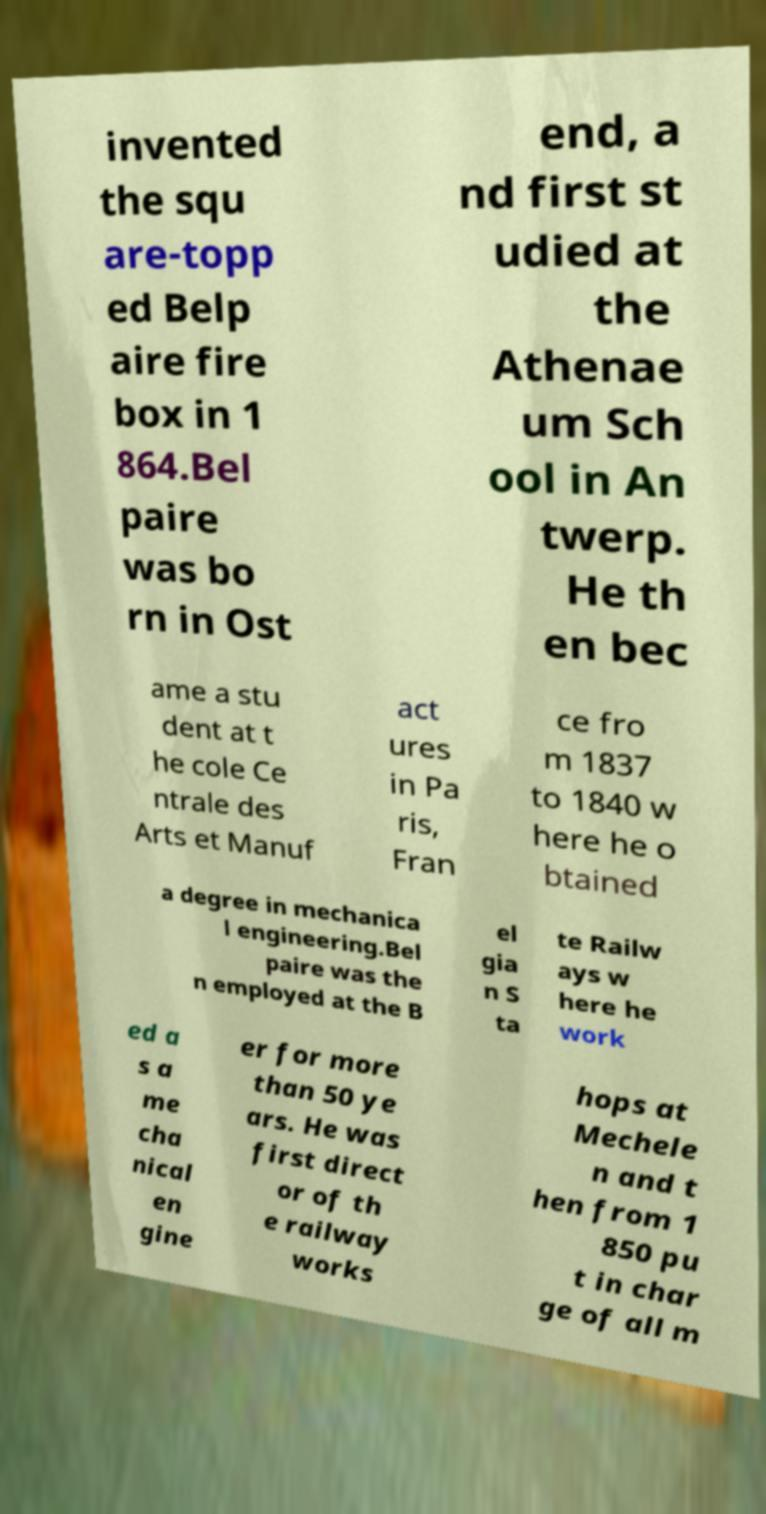Please identify and transcribe the text found in this image. invented the squ are-topp ed Belp aire fire box in 1 864.Bel paire was bo rn in Ost end, a nd first st udied at the Athenae um Sch ool in An twerp. He th en bec ame a stu dent at t he cole Ce ntrale des Arts et Manuf act ures in Pa ris, Fran ce fro m 1837 to 1840 w here he o btained a degree in mechanica l engineering.Bel paire was the n employed at the B el gia n S ta te Railw ays w here he work ed a s a me cha nical en gine er for more than 50 ye ars. He was first direct or of th e railway works hops at Mechele n and t hen from 1 850 pu t in char ge of all m 